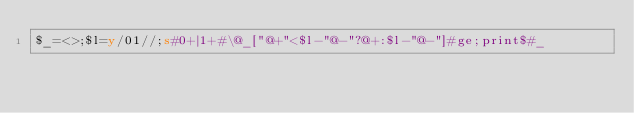Convert code to text. <code><loc_0><loc_0><loc_500><loc_500><_Perl_>$_=<>;$l=y/01//;s#0+|1+#\@_["@+"<$l-"@-"?@+:$l-"@-"]#ge;print$#_</code> 